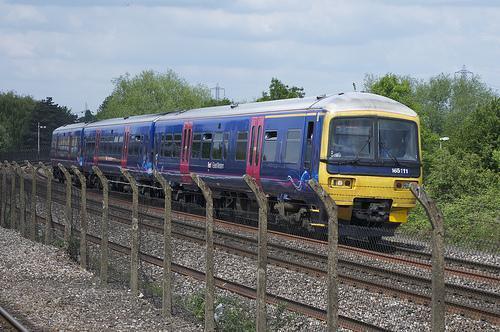How many windows are on the front of the train?
Give a very brief answer. 2. How many train cars can be seen?
Give a very brief answer. 3. How many trains are in the scene?
Give a very brief answer. 1. 